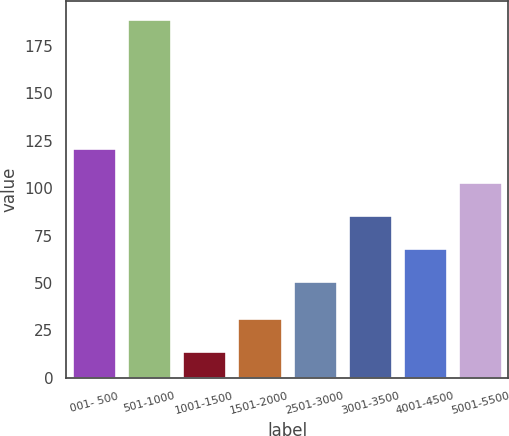<chart> <loc_0><loc_0><loc_500><loc_500><bar_chart><fcel>001- 500<fcel>501-1000<fcel>1001-1500<fcel>1501-2000<fcel>2501-3000<fcel>3001-3500<fcel>4001-4500<fcel>5001-5500<nl><fcel>121<fcel>189<fcel>14<fcel>31.5<fcel>51<fcel>86<fcel>68.5<fcel>103.5<nl></chart> 